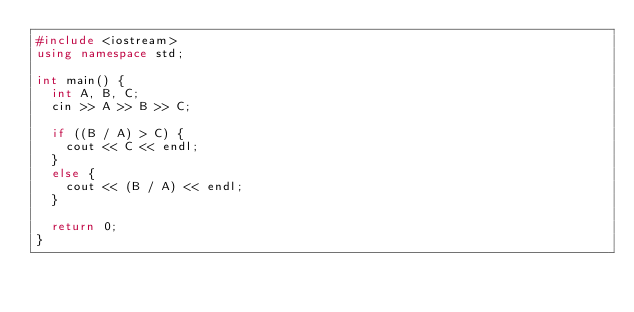<code> <loc_0><loc_0><loc_500><loc_500><_C++_>#include <iostream>
using namespace std;

int main() {
  int A, B, C;
  cin >> A >> B >> C;

  if ((B / A) > C) {
    cout << C << endl;
  }
  else {
    cout << (B / A) << endl;
  }

  return 0;
}</code> 